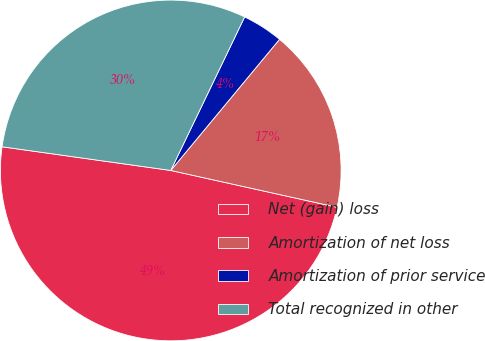Convert chart. <chart><loc_0><loc_0><loc_500><loc_500><pie_chart><fcel>Net (gain) loss<fcel>Amortization of net loss<fcel>Amortization of prior service<fcel>Total recognized in other<nl><fcel>48.75%<fcel>17.45%<fcel>3.88%<fcel>29.92%<nl></chart> 